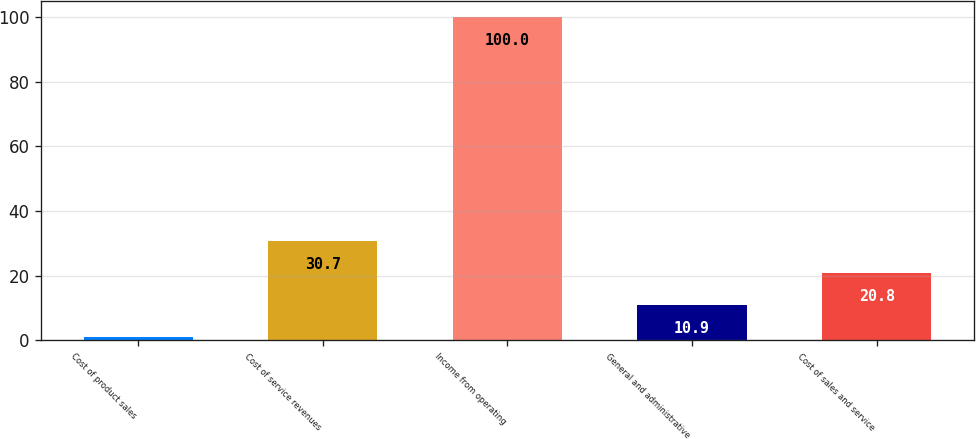Convert chart. <chart><loc_0><loc_0><loc_500><loc_500><bar_chart><fcel>Cost of product sales<fcel>Cost of service revenues<fcel>Income from operating<fcel>General and administrative<fcel>Cost of sales and service<nl><fcel>1<fcel>30.7<fcel>100<fcel>10.9<fcel>20.8<nl></chart> 